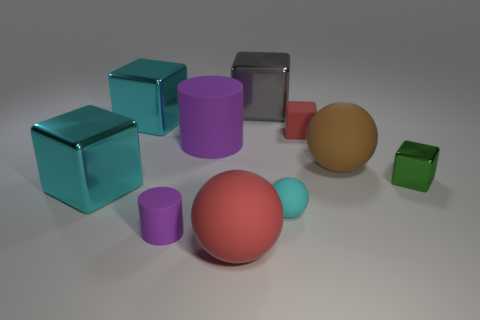Is there any other thing that is made of the same material as the red cube?
Keep it short and to the point. Yes. There is a big brown thing that is the same shape as the big red rubber object; what is its material?
Ensure brevity in your answer.  Rubber. Are there the same number of large gray things that are on the left side of the gray metal cube and tiny cyan matte balls?
Your answer should be compact. No. What size is the block that is in front of the large brown object and to the left of the gray metal thing?
Your answer should be compact. Large. Is there any other thing that is the same color as the tiny matte cylinder?
Offer a very short reply. Yes. How big is the cyan object to the right of the purple thing behind the small rubber cylinder?
Your response must be concise. Small. What color is the thing that is both on the right side of the large purple rubber thing and in front of the tiny ball?
Provide a short and direct response. Red. How many other objects are the same size as the red block?
Offer a terse response. 3. There is a gray metal cube; is it the same size as the ball that is on the left side of the cyan matte object?
Provide a short and direct response. Yes. The rubber cylinder that is the same size as the brown object is what color?
Ensure brevity in your answer.  Purple. 